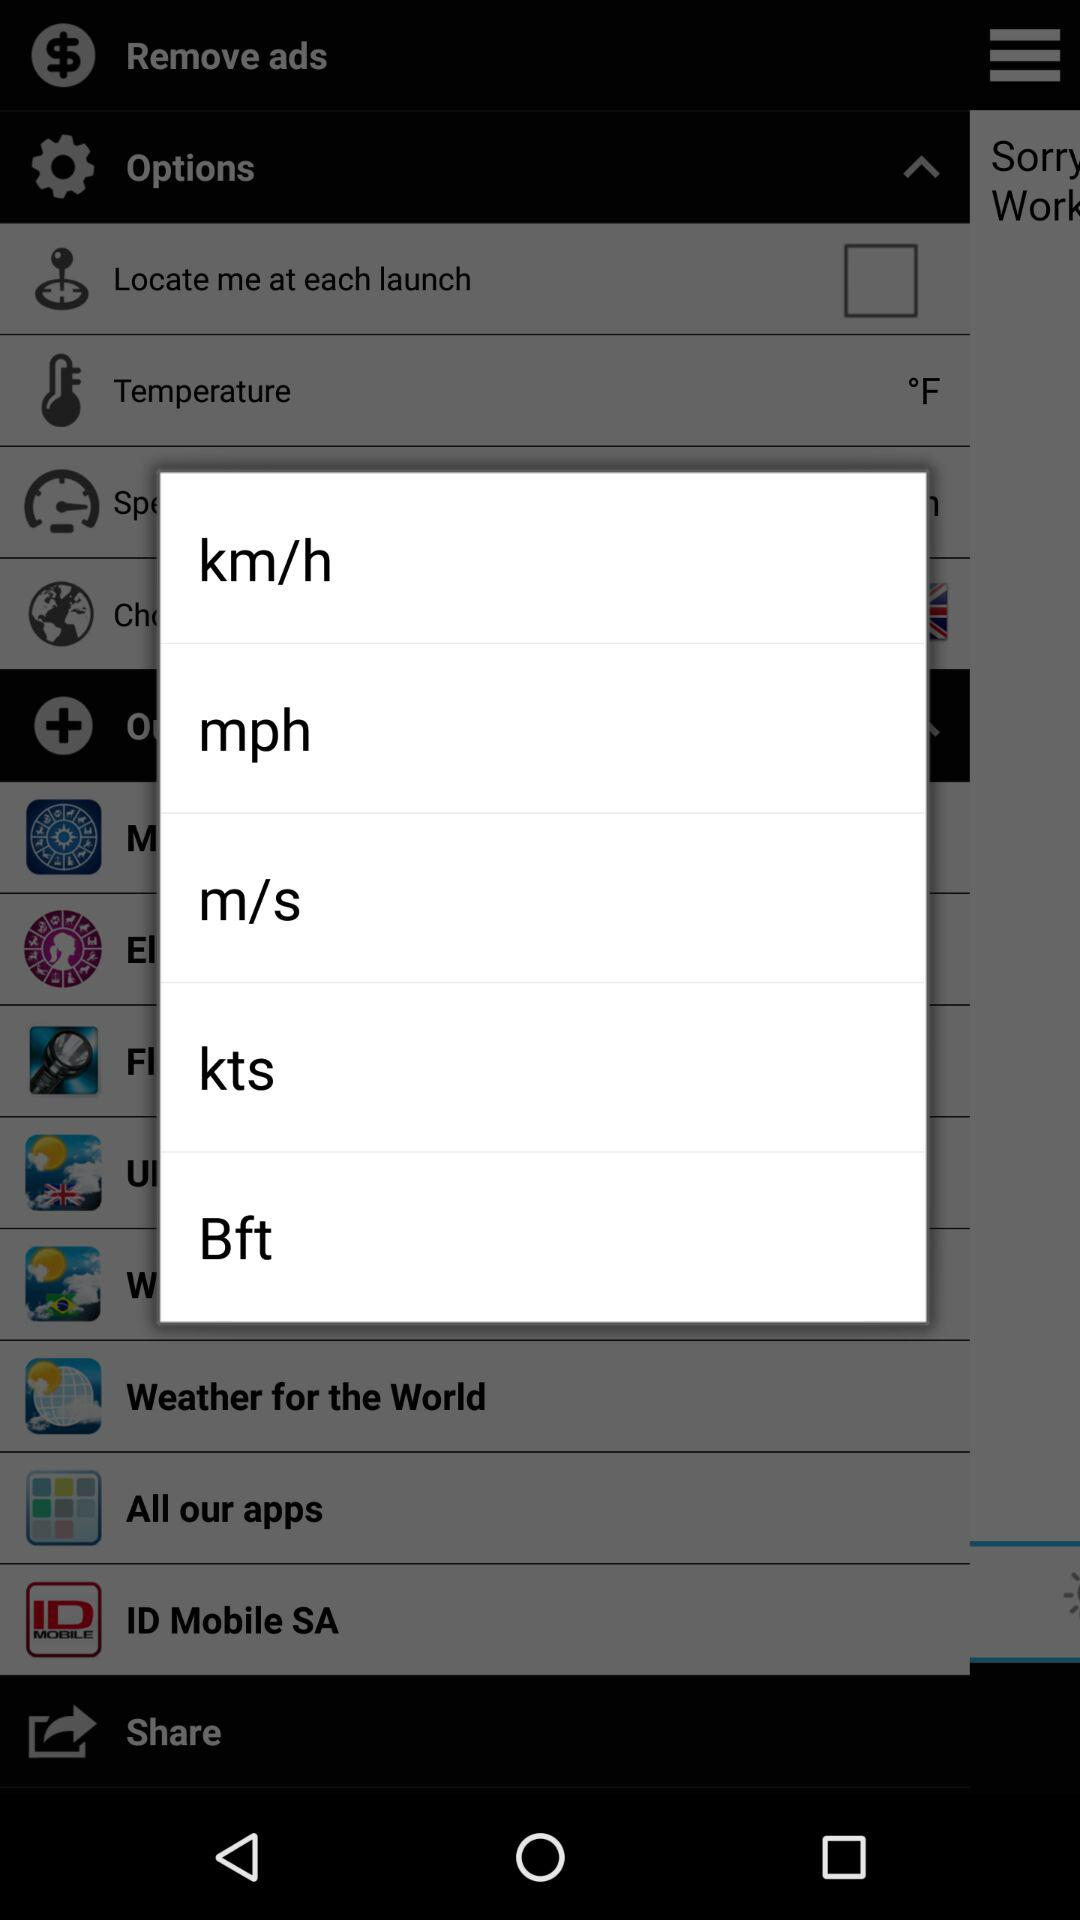What is the given temperature unit? The given temperature unit is °F. 